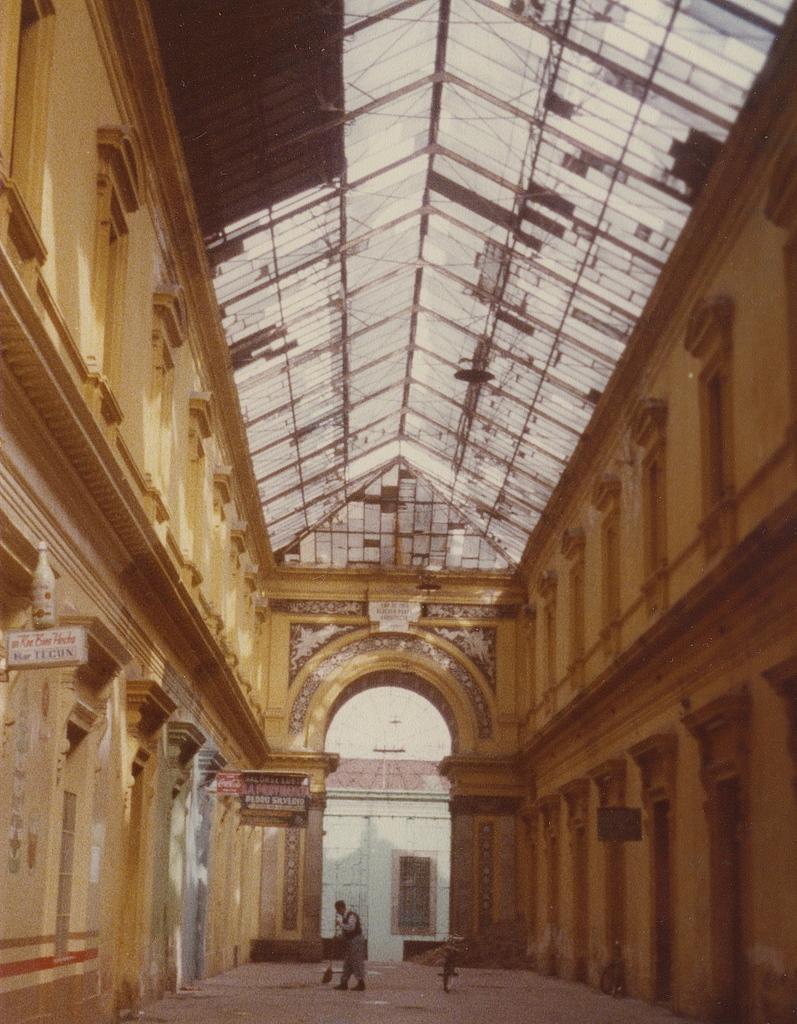Can you describe this image briefly? In this image I can see inside view of a building. In the background I can see a person is standing and in him I can see a bicycle. On the left side of this image I can see a white board and on it I can see something is written. 